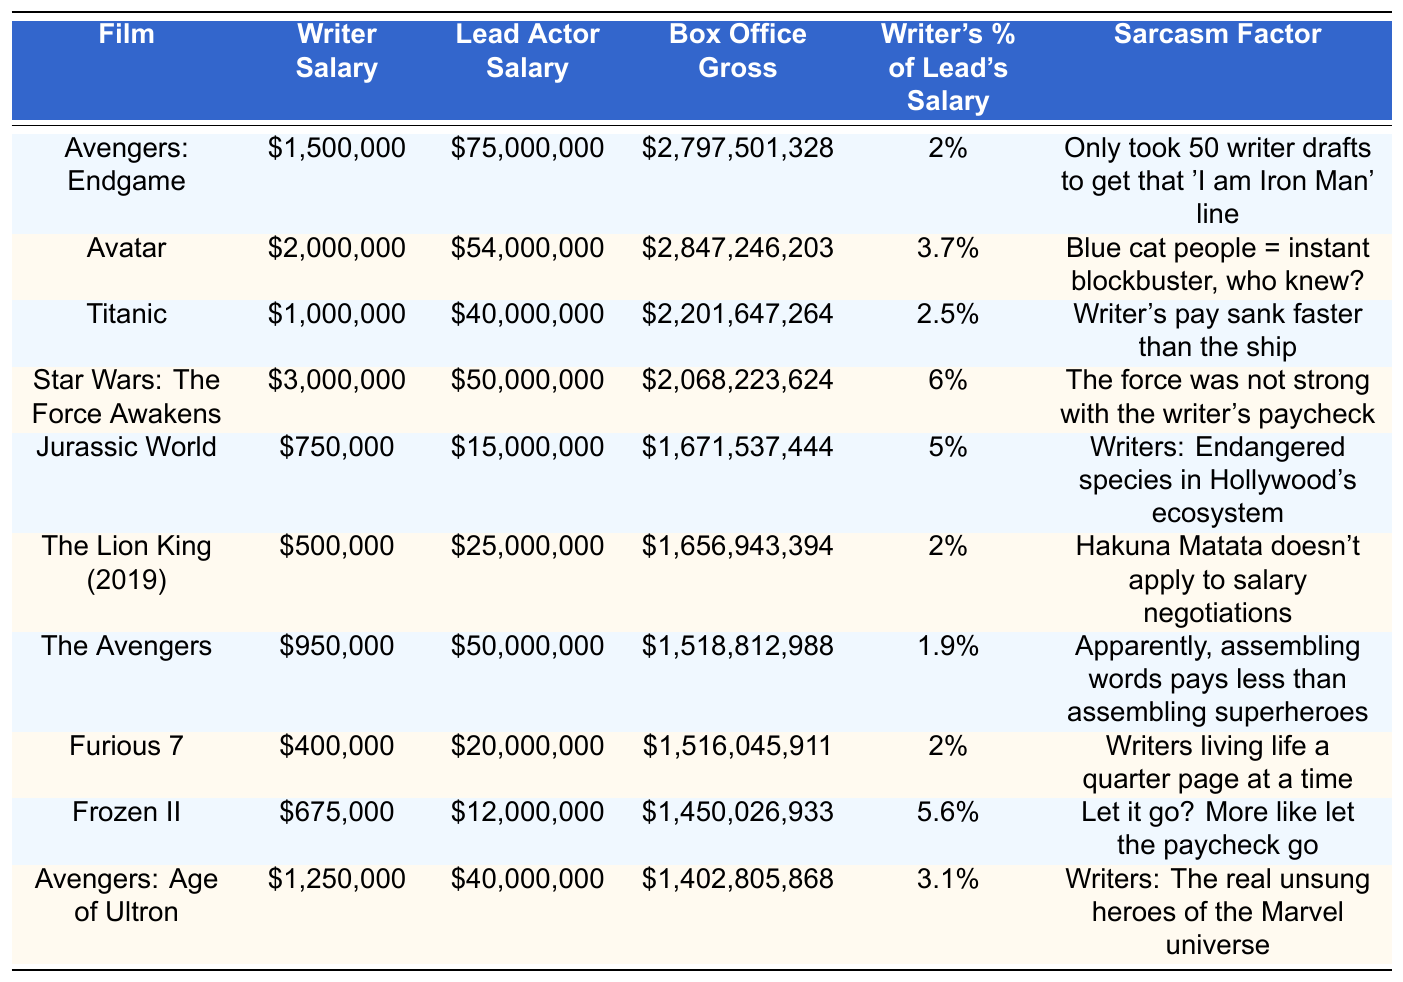What is the highest writer salary among the films listed? The highest writer salary can be retrieved from the "Writer Salary" column. By examining the values, I see that the highest writer salary is $3,000,000 for "Star Wars: The Force Awakens."
Answer: $3,000,000 Which film has the largest box office gross? By reviewing the "Box Office Gross" column, I find that "Avengers: Endgame" has the largest box office gross of $2,797,501,328.
Answer: $2,797,501,328 What percentage of the lead actor's salary does the writer earn in "Jurassic World"? To find the percentage for "Jurassic World", I look at the "Writer's % of Lead's Salary" column, which indicates that the writer earns 5% of the lead actor's salary.
Answer: 5% How much less did the writer of "Furious 7" earn compared to the lead actor? The writer's salary for "Furious 7" is $400,000, and the lead actor's salary is $20,000,000. By calculating the difference: $20,000,000 - $400,000 = $19,600,000.
Answer: $19,600,000 Is it true that writers earn more than 5% of lead actors' salaries in "Avatar"? I check the "Writer's % of Lead's Salary" for "Avatar", which shows it is 3.7%. Since 3.7% is less than 5%, the statement is false.
Answer: No What is the average writer salary across all the films listed? To find the average writer salary, I sum all the writer salaries: $1,500,000 + $2,000,000 + $1,000,000 + $3,000,000 + $750,000 + $500,000 + $950,000 + $400,000 + $675,000 + $1,250,000 = $12,025,000. There are 10 films, so I divide: $12,025,000 / 10 = $1,202,500.
Answer: $1,202,500 Which film has the largest disparity between the writer's salary and the lead actor's salary based on the data? I compute the differences by subtracting each writer's salary from the corresponding lead actor's salary. The largest disparity is found in "Avengers: Endgame" where the difference is $75,000,000 - $1,500,000 = $73,500,000.
Answer: "Avengers: Endgame" For which film does the writer earn the least relative to the lead actor's salary? I look for the smallest percentage in the "Writer's % of Lead's Salary" column. The minimum is 1.9% for "The Avengers."
Answer: "The Avengers" Is it true that every film listed has a box office gross of over $1 billion? By checking the "Box Office Gross" column, all listed films have gross amounts above $1 billion, confirming that the statement is true.
Answer: Yes What does the sarcasm factor suggest about the writer's pay in "Frozen II"? The sarcasm for "Frozen II" states “Let it go? More like let the paycheck go,” indicating a negative sentiment regarding the writer’s salary compared to expectations.
Answer: Negative sentiment 